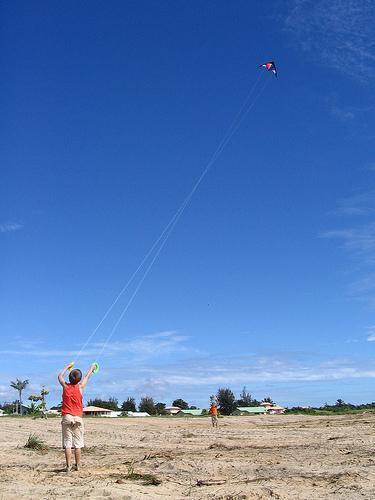How many children are there?
Give a very brief answer. 2. 